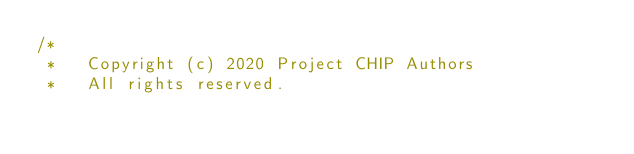<code> <loc_0><loc_0><loc_500><loc_500><_Kotlin_>/*
 *   Copyright (c) 2020 Project CHIP Authors
 *   All rights reserved.</code> 